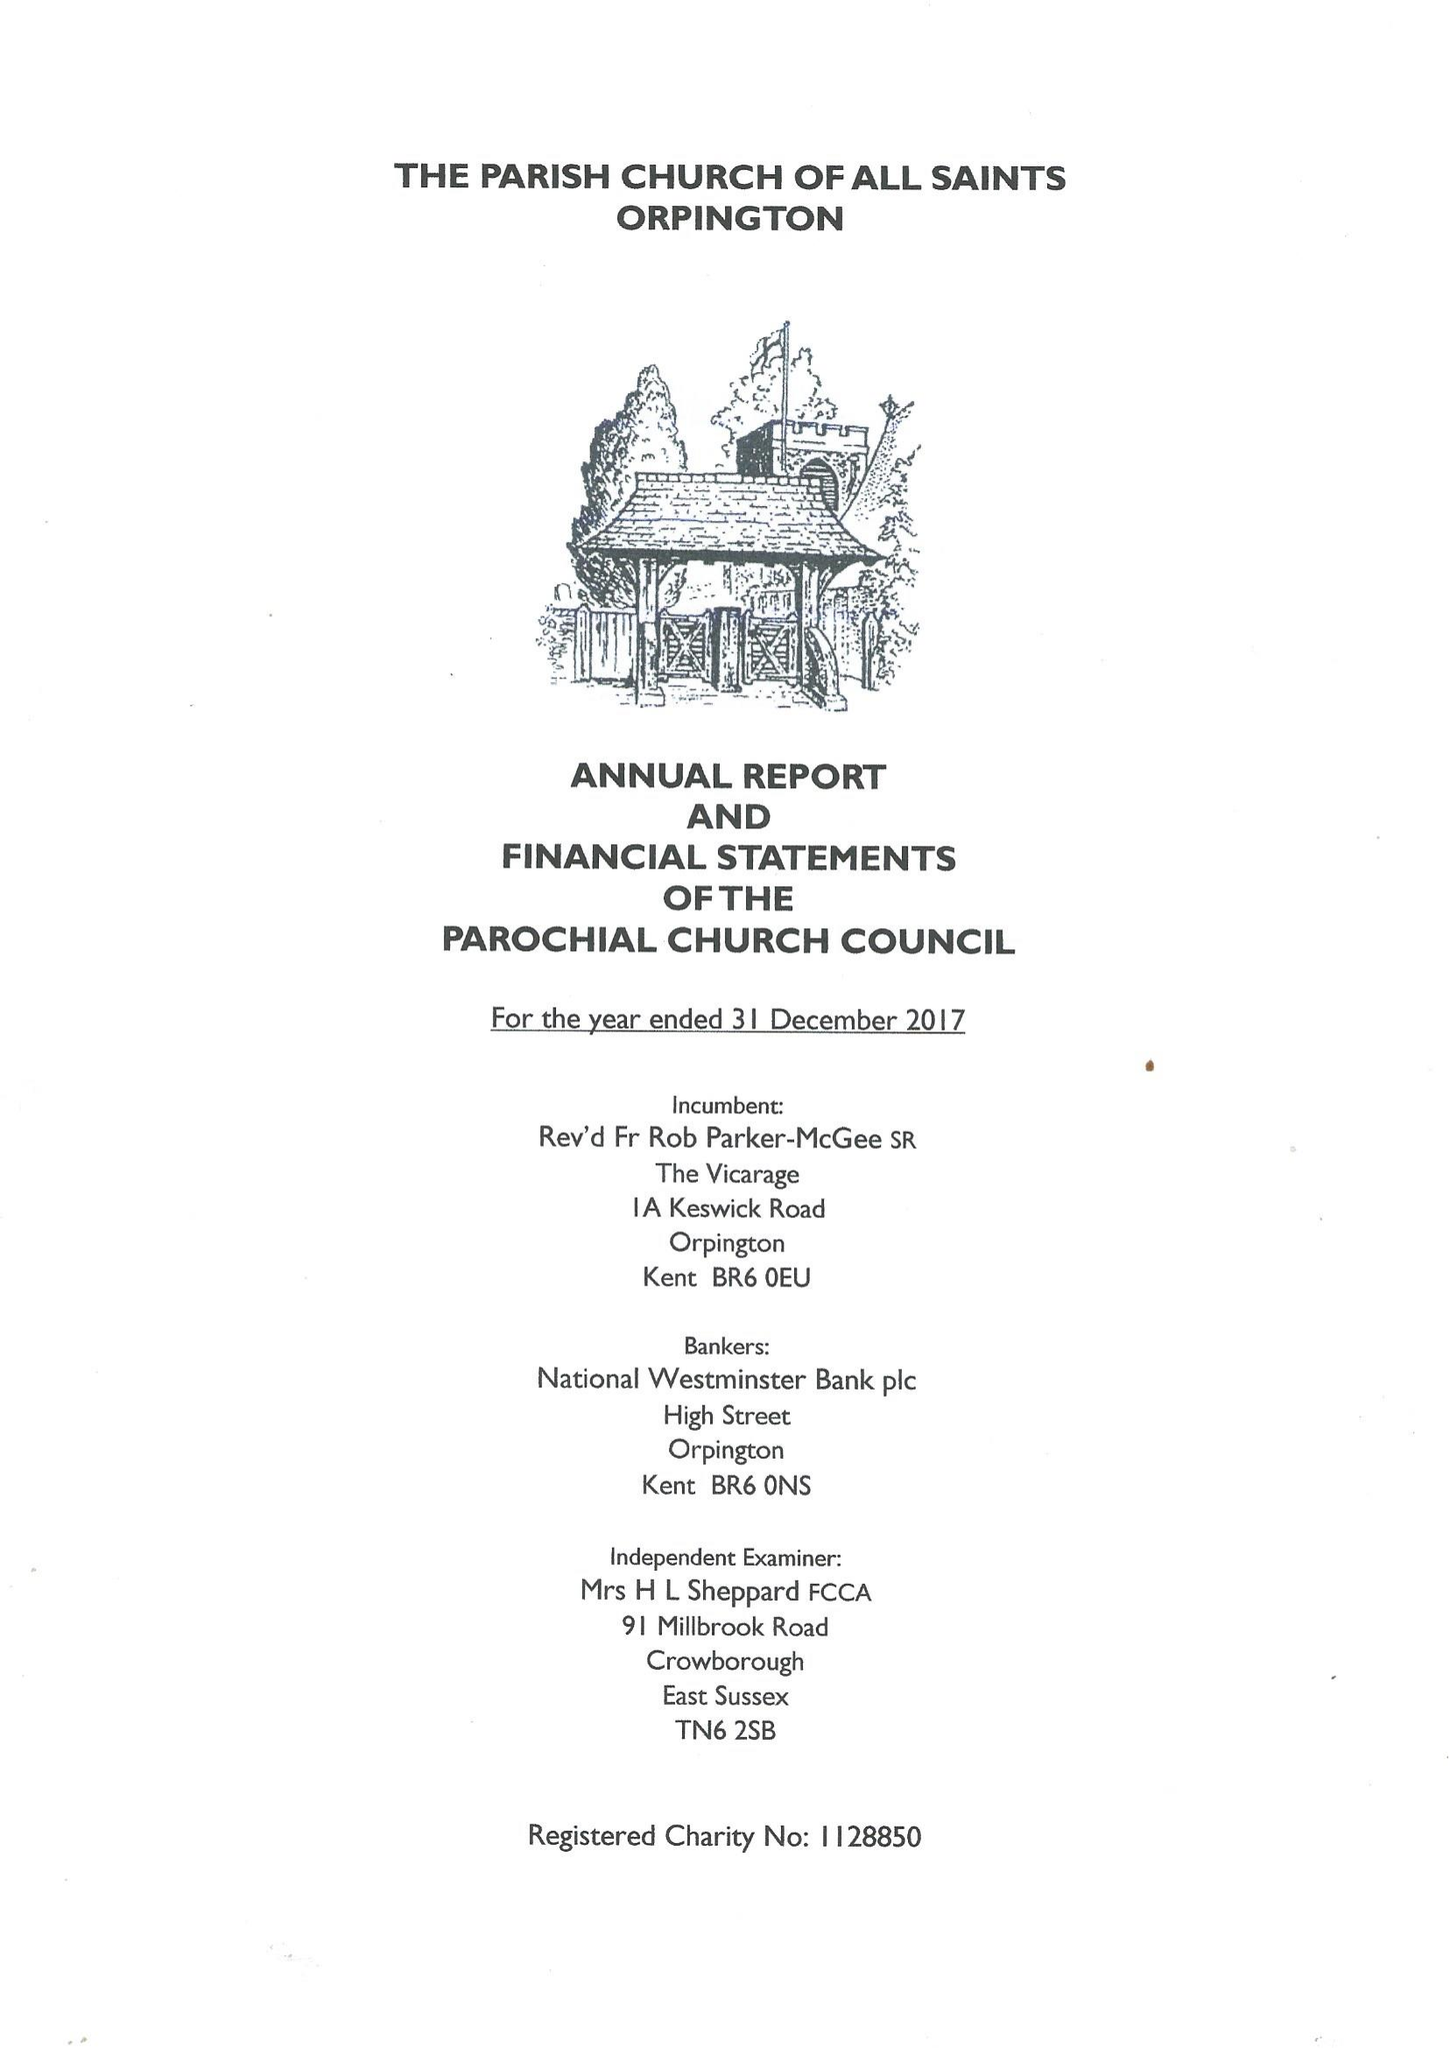What is the value for the address__post_town?
Answer the question using a single word or phrase. ORPINGTON 